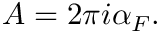Convert formula to latex. <formula><loc_0><loc_0><loc_500><loc_500>A = 2 \pi i \alpha _ { F } .</formula> 